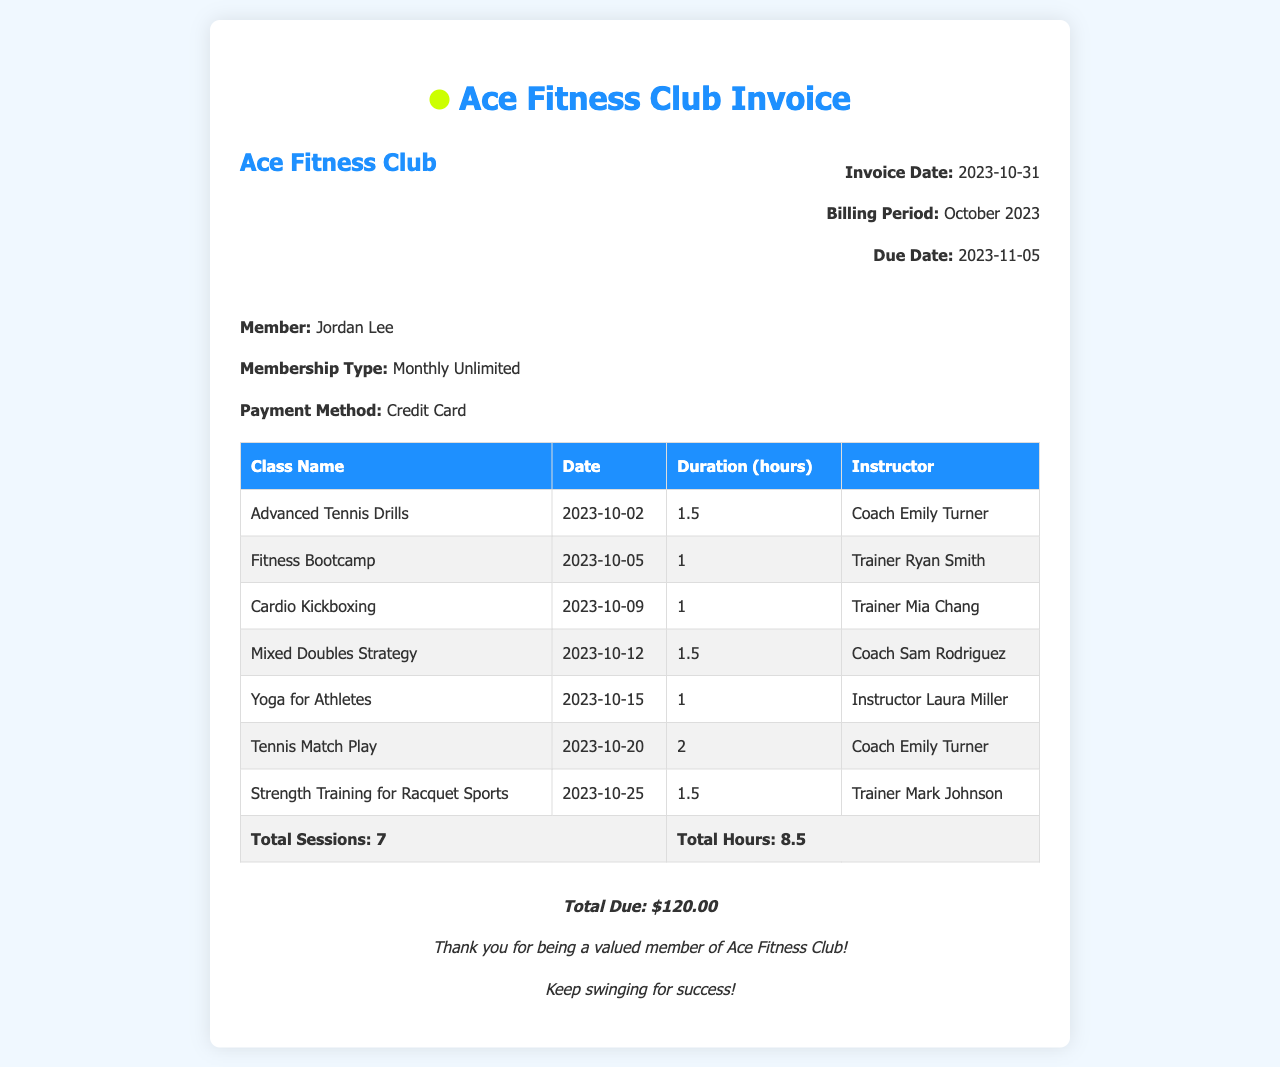What is the member's name? The member's name is mentioned in the member info section of the document.
Answer: Jordan Lee What is the total number of sessions attended? The total sessions are summarized at the end of the classes table in the document.
Answer: 7 Who is the instructor for the Advanced Tennis Drills class? The instructor's name for each class is listed in the corresponding row of the classes table.
Answer: Coach Emily Turner What is the duration of the Tennis Match Play class? The duration for each class is specified in hours in the classes table.
Answer: 2 What is the total due amount? The total due is clearly stated at the bottom of the invoice.
Answer: $120.00 How many fitness classes were attended? Fitness classes are those that focus on general fitness rather than racquet sports, which can be inferred from the class names.
Answer: 3 What is the payment method used for the membership? The payment method is noted in the member info section of the document.
Answer: Credit Card What date is the invoice due? The due date is listed in the invoice details section.
Answer: 2023-11-05 Which class was taught by Trainer Ryan Smith? Each class instructor is detailed in the corresponding row of the classes table, and this helps identify which class they taught.
Answer: Fitness Bootcamp 